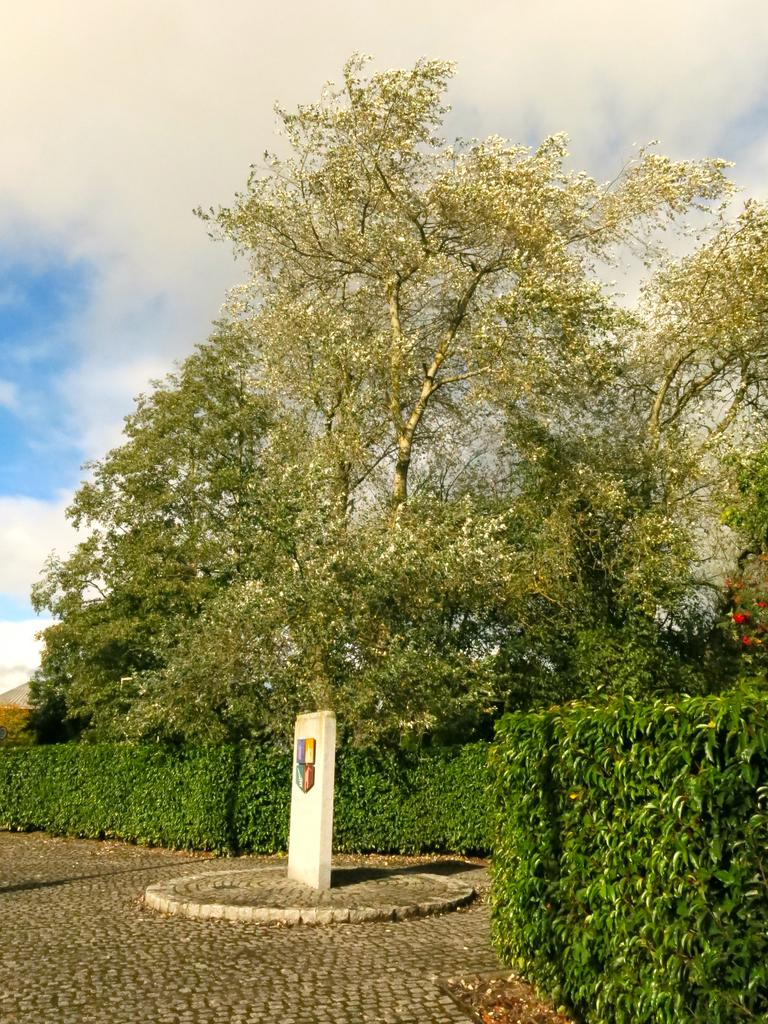What is the main object in the image? There is a stone in the image. What is depicted on the stone? The stone has shields on it. Where is the stone located? The stone is on the ground. What type of vegetation is present in the image? Grass is present in the image. What other natural elements can be seen in the image? Trees are visible in the image. What is visible in the background of the image? The sky is visible in the background, and clouds are present in the sky. What type of mint is growing on the stone in the image? There is no mint growing on the stone in the image; it only has shields depicted on it. How many socks are visible on the stone in the image? There are no socks present in the image; it only features a stone with shields on it. 